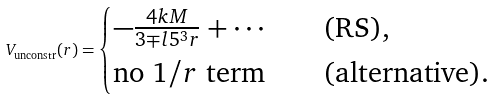<formula> <loc_0><loc_0><loc_500><loc_500>V _ { \text {unconstr} } ( r ) = \begin{cases} - \frac { 4 k M } { 3 \mp l { 5 } ^ { 3 } r } + \cdots \quad & \text {(RS),} \\ \text {no $1/r$ term} \quad & \text {(alternative)} . \end{cases}</formula> 